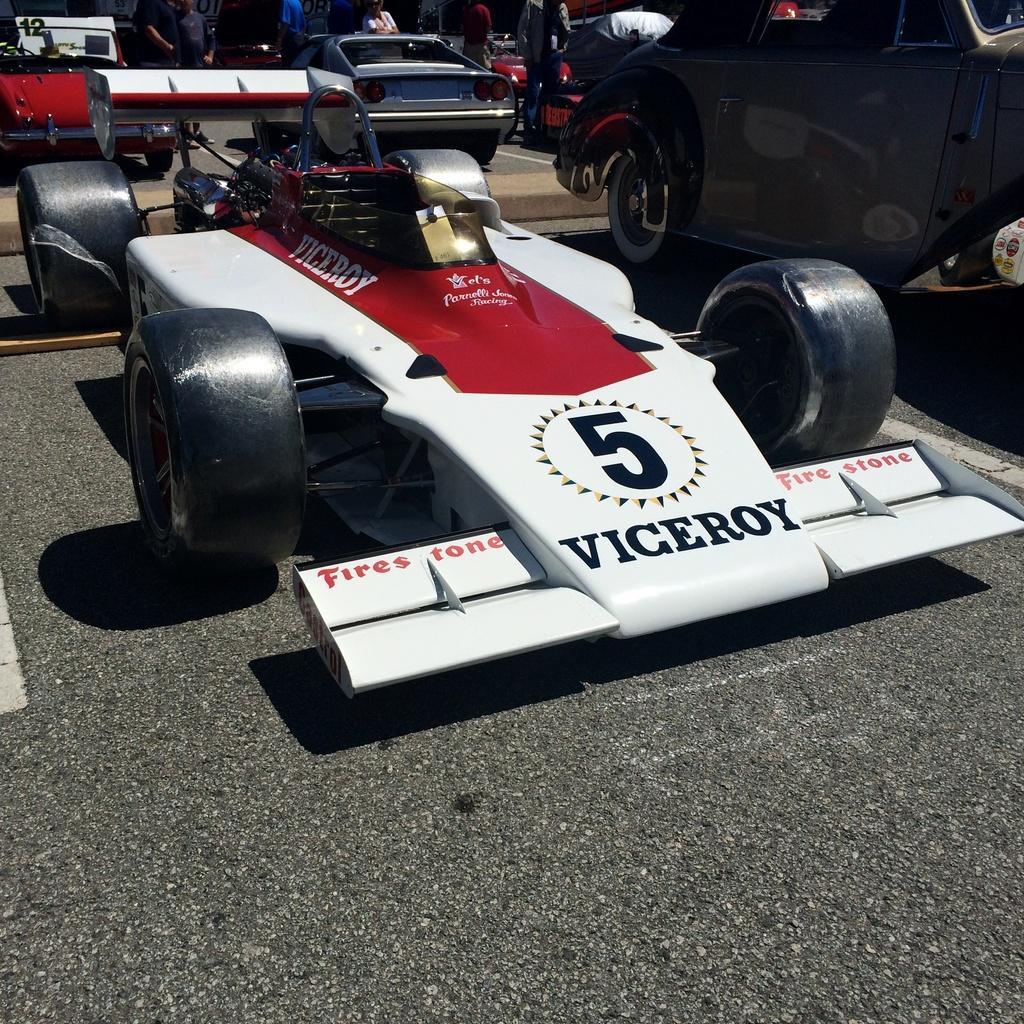Could you give a brief overview of what you see in this image? In this image I can see car which is in white and red color, at the background I can see few vehicles and few persons standing. 